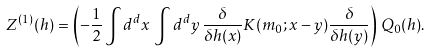Convert formula to latex. <formula><loc_0><loc_0><loc_500><loc_500>Z ^ { ( 1 ) } ( h ) = \left ( - \frac { 1 } { 2 } \int d ^ { d } x \, \int d ^ { d } y \, \frac { \delta } { \delta h ( x ) } K ( m _ { 0 } ; x - y ) \frac { \delta } { \delta h ( y ) } \right ) \, Q _ { 0 } ( h ) .</formula> 